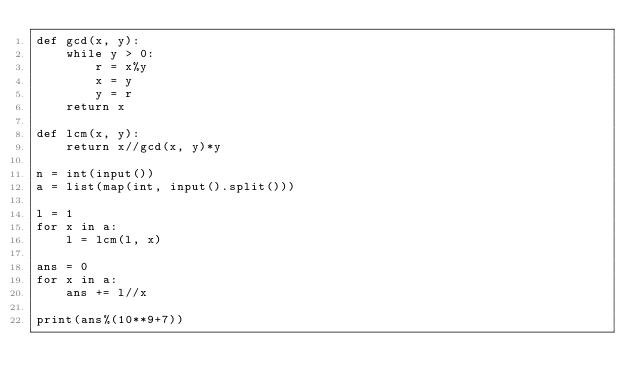Convert code to text. <code><loc_0><loc_0><loc_500><loc_500><_Python_>def gcd(x, y):
    while y > 0:
        r = x%y
        x = y
        y = r
    return x

def lcm(x, y):
    return x//gcd(x, y)*y

n = int(input())
a = list(map(int, input().split()))

l = 1
for x in a:
    l = lcm(l, x)

ans = 0
for x in a:
    ans += l//x

print(ans%(10**9+7))</code> 